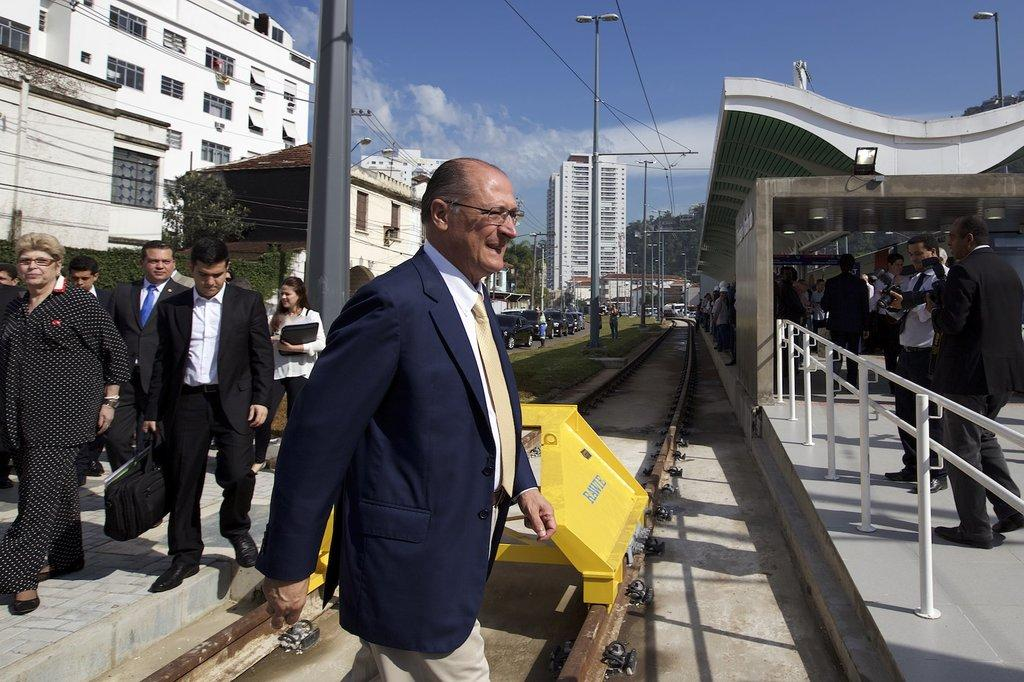Who or what can be seen in the image? There are people in the image. What structures are visible in the image? There are buildings in the image. What else can be seen in the image besides people and buildings? There are poles and trees in the image. What type of silver object is being used for writing in the image? There is no silver object or writing activity present in the image. What punishment is being administered to the people in the image? There is no punishment being administered to the people in the image; they are simply present in the scene. 